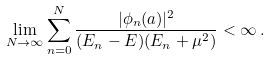<formula> <loc_0><loc_0><loc_500><loc_500>\lim _ { N \to \infty } \sum _ { n = 0 } ^ { N } \frac { | \phi _ { n } ( a ) | ^ { 2 } } { ( E _ { n } - E ) ( E _ { n } + \mu ^ { 2 } ) } < \infty \, .</formula> 